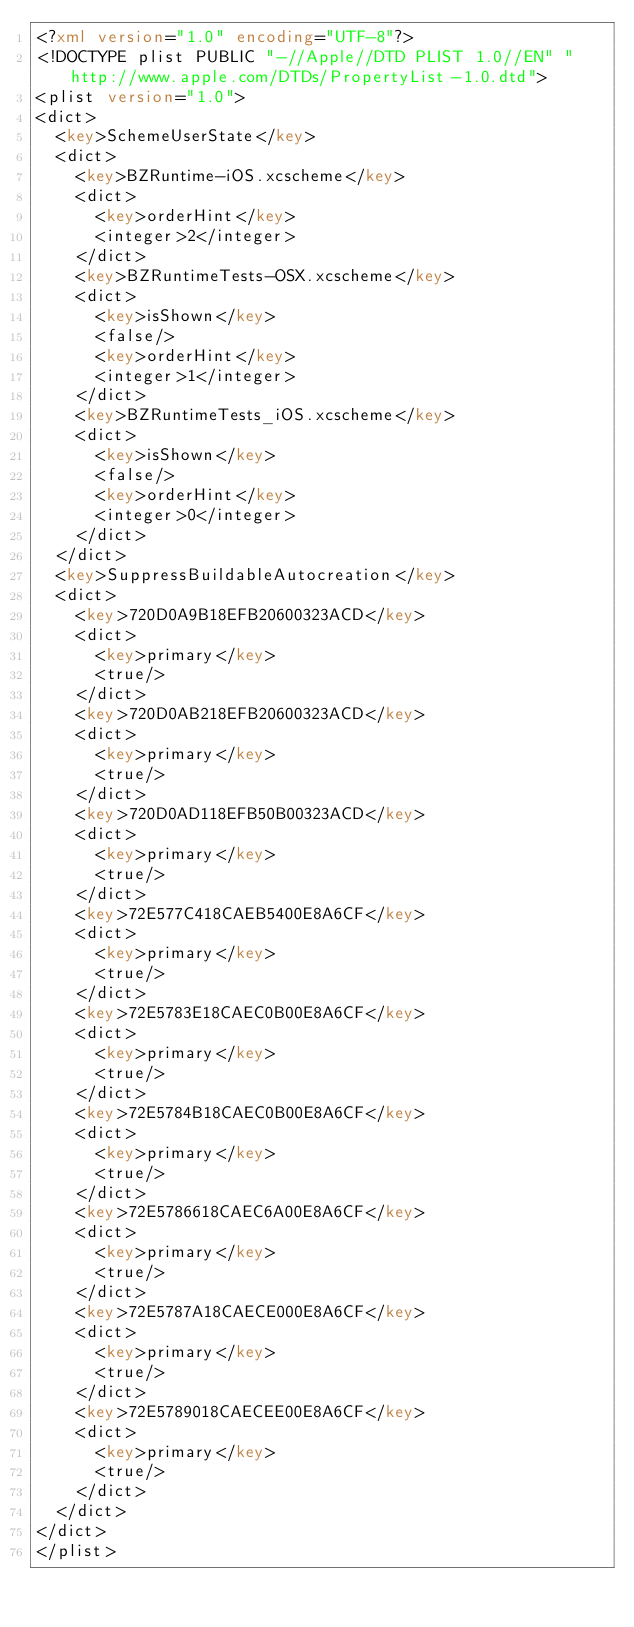<code> <loc_0><loc_0><loc_500><loc_500><_XML_><?xml version="1.0" encoding="UTF-8"?>
<!DOCTYPE plist PUBLIC "-//Apple//DTD PLIST 1.0//EN" "http://www.apple.com/DTDs/PropertyList-1.0.dtd">
<plist version="1.0">
<dict>
	<key>SchemeUserState</key>
	<dict>
		<key>BZRuntime-iOS.xcscheme</key>
		<dict>
			<key>orderHint</key>
			<integer>2</integer>
		</dict>
		<key>BZRuntimeTests-OSX.xcscheme</key>
		<dict>
			<key>isShown</key>
			<false/>
			<key>orderHint</key>
			<integer>1</integer>
		</dict>
		<key>BZRuntimeTests_iOS.xcscheme</key>
		<dict>
			<key>isShown</key>
			<false/>
			<key>orderHint</key>
			<integer>0</integer>
		</dict>
	</dict>
	<key>SuppressBuildableAutocreation</key>
	<dict>
		<key>720D0A9B18EFB20600323ACD</key>
		<dict>
			<key>primary</key>
			<true/>
		</dict>
		<key>720D0AB218EFB20600323ACD</key>
		<dict>
			<key>primary</key>
			<true/>
		</dict>
		<key>720D0AD118EFB50B00323ACD</key>
		<dict>
			<key>primary</key>
			<true/>
		</dict>
		<key>72E577C418CAEB5400E8A6CF</key>
		<dict>
			<key>primary</key>
			<true/>
		</dict>
		<key>72E5783E18CAEC0B00E8A6CF</key>
		<dict>
			<key>primary</key>
			<true/>
		</dict>
		<key>72E5784B18CAEC0B00E8A6CF</key>
		<dict>
			<key>primary</key>
			<true/>
		</dict>
		<key>72E5786618CAEC6A00E8A6CF</key>
		<dict>
			<key>primary</key>
			<true/>
		</dict>
		<key>72E5787A18CAECE000E8A6CF</key>
		<dict>
			<key>primary</key>
			<true/>
		</dict>
		<key>72E5789018CAECEE00E8A6CF</key>
		<dict>
			<key>primary</key>
			<true/>
		</dict>
	</dict>
</dict>
</plist>
</code> 